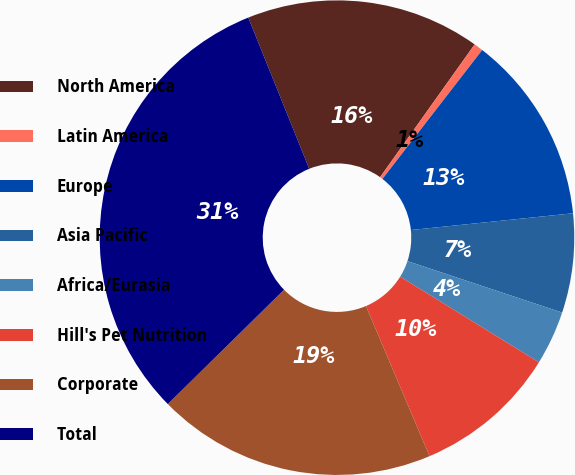Convert chart. <chart><loc_0><loc_0><loc_500><loc_500><pie_chart><fcel>North America<fcel>Latin America<fcel>Europe<fcel>Asia Pacific<fcel>Africa/Eurasia<fcel>Hill's Pet Nutrition<fcel>Corporate<fcel>Total<nl><fcel>15.95%<fcel>0.63%<fcel>12.88%<fcel>6.75%<fcel>3.69%<fcel>9.82%<fcel>19.01%<fcel>31.27%<nl></chart> 